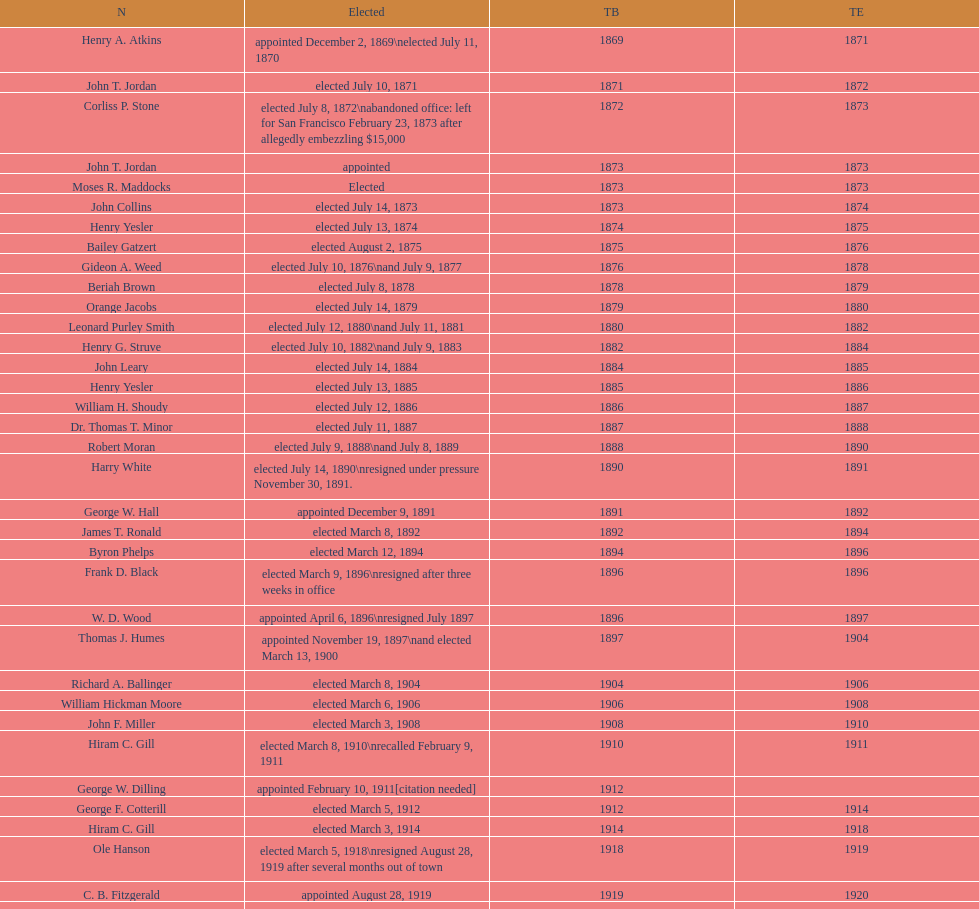How many women have been elected mayor of seattle, washington? 1. 